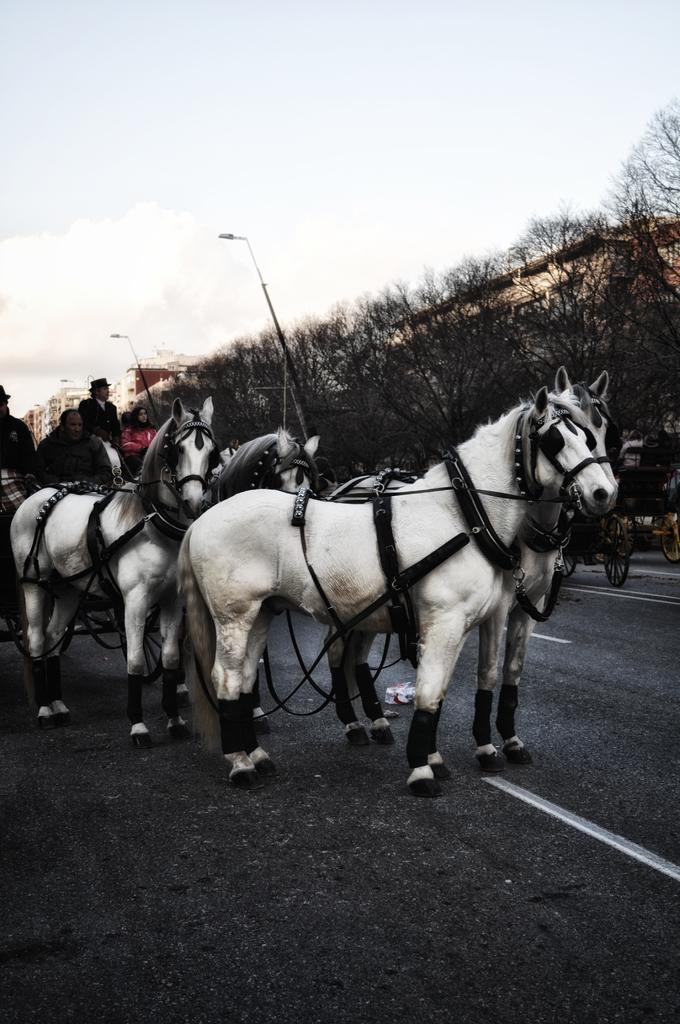What are the people in the image doing? The people in the image are sitting on a cart. What is pulling the cart in the image? There are horses on the road that are likely pulling the cart. What can be seen in the background of the image? There are trees, lights on poles, and the sky visible in the background. What type of plant is being used as a cabbage substitute in the image? There is no plant or cabbage present in the image. What type of meat is being served on the cart in the image? There is no meat present in the image; it only shows people sitting on a cart and horses on the road. 